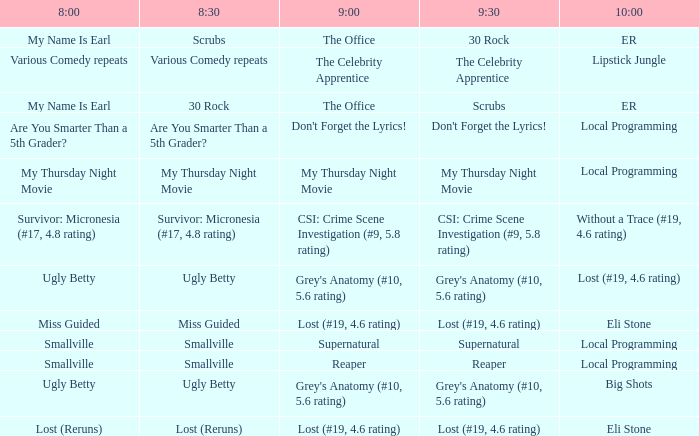What is at 10:00 when at 9:00 it is lost (#19, 4.6 rating) and at 8:30 it is lost (reruns)? Eli Stone. 